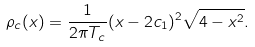Convert formula to latex. <formula><loc_0><loc_0><loc_500><loc_500>\rho _ { c } ( x ) = \frac { 1 } { 2 \pi T _ { c } } ( x - 2 c _ { 1 } ) ^ { 2 } \sqrt { 4 - x ^ { 2 } } .</formula> 